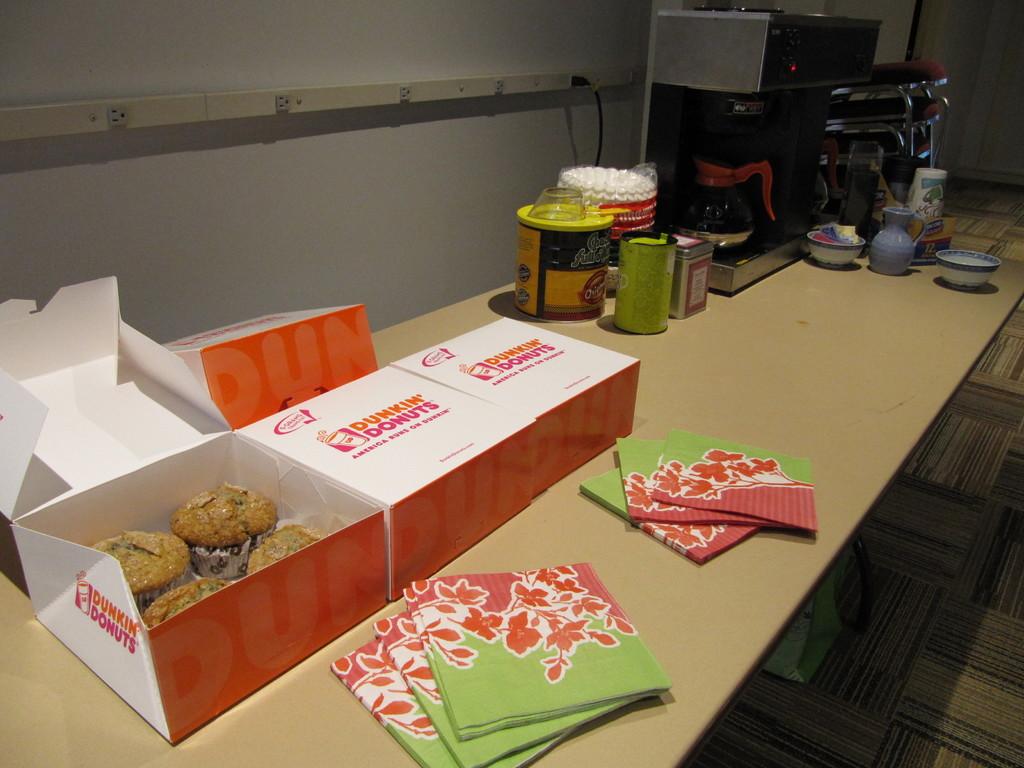Who are the muffins from?
Provide a short and direct response. Dunkin donuts. 